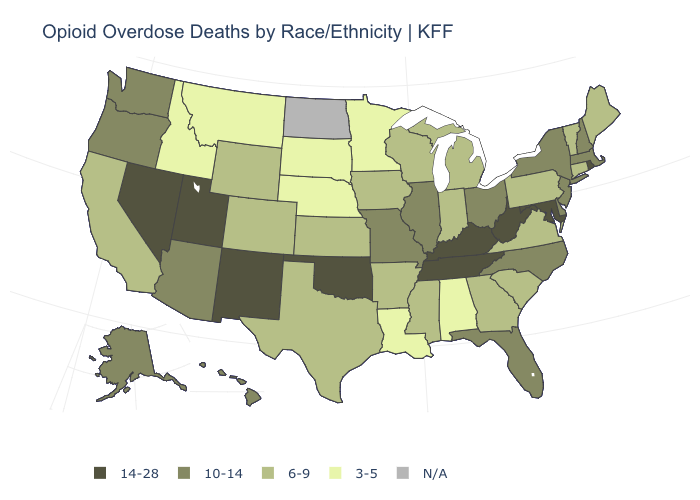What is the highest value in states that border Maine?
Short answer required. 10-14. Is the legend a continuous bar?
Be succinct. No. What is the lowest value in states that border Indiana?
Answer briefly. 6-9. Does the first symbol in the legend represent the smallest category?
Short answer required. No. What is the value of Washington?
Keep it brief. 10-14. What is the value of Montana?
Answer briefly. 3-5. What is the value of California?
Concise answer only. 6-9. What is the highest value in states that border Maine?
Be succinct. 10-14. What is the lowest value in the USA?
Concise answer only. 3-5. What is the value of Arkansas?
Give a very brief answer. 6-9. What is the value of New Hampshire?
Quick response, please. 10-14. Is the legend a continuous bar?
Quick response, please. No. Among the states that border Kansas , which have the lowest value?
Concise answer only. Nebraska. Which states have the lowest value in the USA?
Concise answer only. Alabama, Idaho, Louisiana, Minnesota, Montana, Nebraska, South Dakota. 